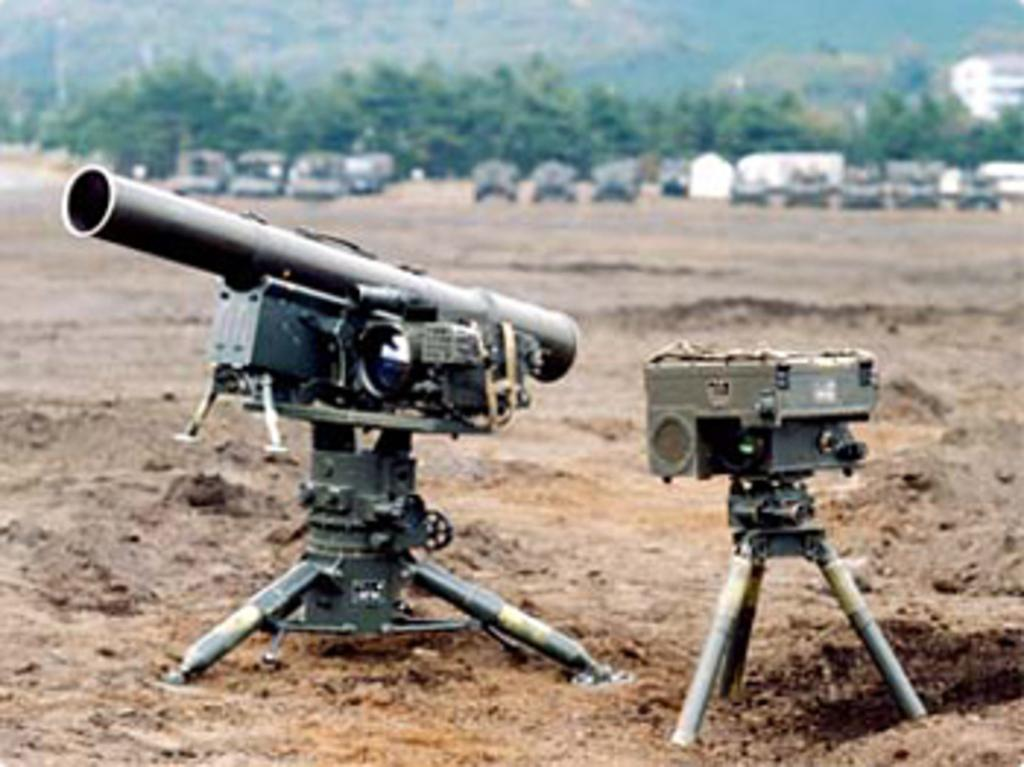What is the main subject of the image? The main subject of the image is a missile system arranged on the ground. What can be seen in the background of the image? In the background, there are vehicles parked, trees, a building, and a hill. Can you describe the arrangement of the missile system? The missile system is arranged on the ground, but the specific arrangement cannot be determined from the image alone. What type of caption is written on the missile system in the image? There is no caption visible on the missile system in the image. What color is the yarn used to tie the missile system together? There is no yarn present in the image; the missile system is arranged on the ground without any visible yarn. 